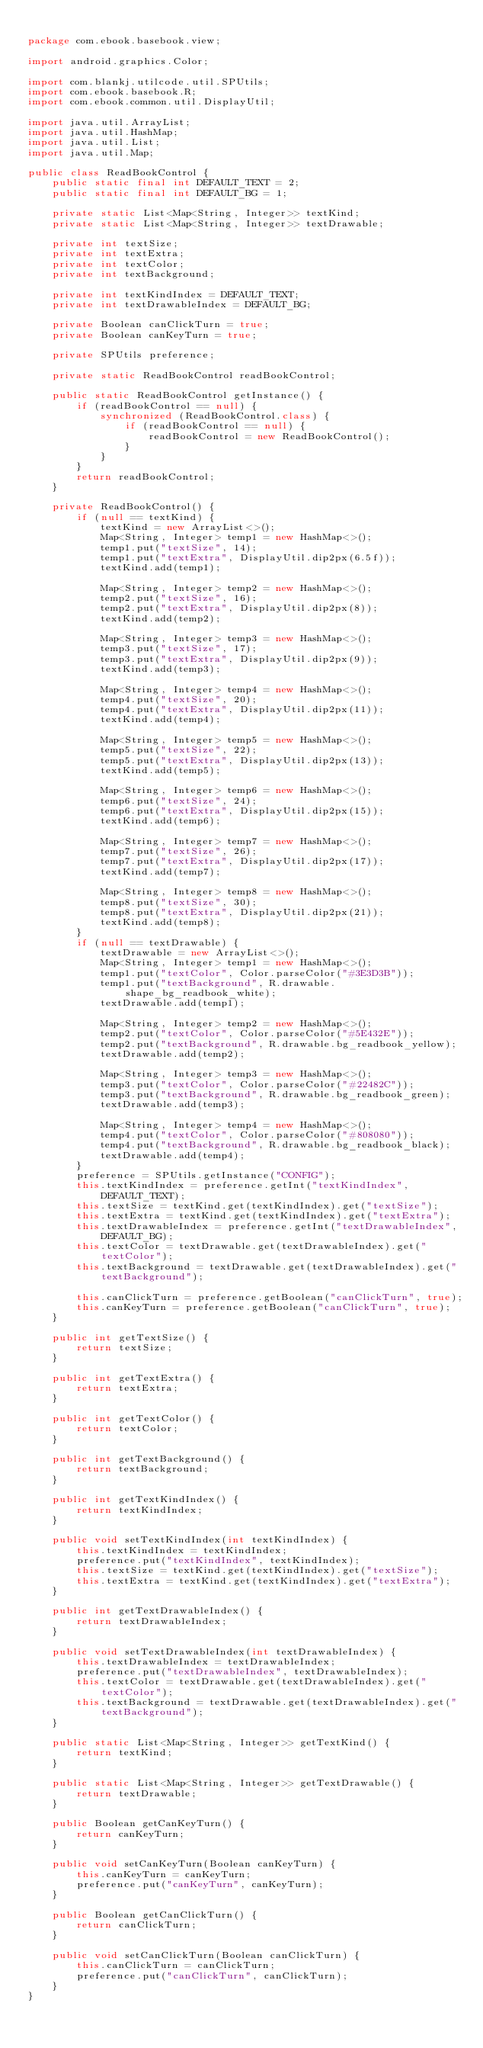<code> <loc_0><loc_0><loc_500><loc_500><_Java_>
package com.ebook.basebook.view;

import android.graphics.Color;

import com.blankj.utilcode.util.SPUtils;
import com.ebook.basebook.R;
import com.ebook.common.util.DisplayUtil;

import java.util.ArrayList;
import java.util.HashMap;
import java.util.List;
import java.util.Map;

public class ReadBookControl {
    public static final int DEFAULT_TEXT = 2;
    public static final int DEFAULT_BG = 1;

    private static List<Map<String, Integer>> textKind;
    private static List<Map<String, Integer>> textDrawable;

    private int textSize;
    private int textExtra;
    private int textColor;
    private int textBackground;

    private int textKindIndex = DEFAULT_TEXT;
    private int textDrawableIndex = DEFAULT_BG;

    private Boolean canClickTurn = true;
    private Boolean canKeyTurn = true;

    private SPUtils preference;

    private static ReadBookControl readBookControl;

    public static ReadBookControl getInstance() {
        if (readBookControl == null) {
            synchronized (ReadBookControl.class) {
                if (readBookControl == null) {
                    readBookControl = new ReadBookControl();
                }
            }
        }
        return readBookControl;
    }

    private ReadBookControl() {
        if (null == textKind) {
            textKind = new ArrayList<>();
            Map<String, Integer> temp1 = new HashMap<>();
            temp1.put("textSize", 14);
            temp1.put("textExtra", DisplayUtil.dip2px(6.5f));
            textKind.add(temp1);

            Map<String, Integer> temp2 = new HashMap<>();
            temp2.put("textSize", 16);
            temp2.put("textExtra", DisplayUtil.dip2px(8));
            textKind.add(temp2);

            Map<String, Integer> temp3 = new HashMap<>();
            temp3.put("textSize", 17);
            temp3.put("textExtra", DisplayUtil.dip2px(9));
            textKind.add(temp3);

            Map<String, Integer> temp4 = new HashMap<>();
            temp4.put("textSize", 20);
            temp4.put("textExtra", DisplayUtil.dip2px(11));
            textKind.add(temp4);

            Map<String, Integer> temp5 = new HashMap<>();
            temp5.put("textSize", 22);
            temp5.put("textExtra", DisplayUtil.dip2px(13));
            textKind.add(temp5);

            Map<String, Integer> temp6 = new HashMap<>();
            temp6.put("textSize", 24);
            temp6.put("textExtra", DisplayUtil.dip2px(15));
            textKind.add(temp6);

            Map<String, Integer> temp7 = new HashMap<>();
            temp7.put("textSize", 26);
            temp7.put("textExtra", DisplayUtil.dip2px(17));
            textKind.add(temp7);

            Map<String, Integer> temp8 = new HashMap<>();
            temp8.put("textSize", 30);
            temp8.put("textExtra", DisplayUtil.dip2px(21));
            textKind.add(temp8);
        }
        if (null == textDrawable) {
            textDrawable = new ArrayList<>();
            Map<String, Integer> temp1 = new HashMap<>();
            temp1.put("textColor", Color.parseColor("#3E3D3B"));
            temp1.put("textBackground", R.drawable.shape_bg_readbook_white);
            textDrawable.add(temp1);

            Map<String, Integer> temp2 = new HashMap<>();
            temp2.put("textColor", Color.parseColor("#5E432E"));
            temp2.put("textBackground", R.drawable.bg_readbook_yellow);
            textDrawable.add(temp2);

            Map<String, Integer> temp3 = new HashMap<>();
            temp3.put("textColor", Color.parseColor("#22482C"));
            temp3.put("textBackground", R.drawable.bg_readbook_green);
            textDrawable.add(temp3);

            Map<String, Integer> temp4 = new HashMap<>();
            temp4.put("textColor", Color.parseColor("#808080"));
            temp4.put("textBackground", R.drawable.bg_readbook_black);
            textDrawable.add(temp4);
        }
        preference = SPUtils.getInstance("CONFIG");
        this.textKindIndex = preference.getInt("textKindIndex", DEFAULT_TEXT);
        this.textSize = textKind.get(textKindIndex).get("textSize");
        this.textExtra = textKind.get(textKindIndex).get("textExtra");
        this.textDrawableIndex = preference.getInt("textDrawableIndex", DEFAULT_BG);
        this.textColor = textDrawable.get(textDrawableIndex).get("textColor");
        this.textBackground = textDrawable.get(textDrawableIndex).get("textBackground");

        this.canClickTurn = preference.getBoolean("canClickTurn", true);
        this.canKeyTurn = preference.getBoolean("canClickTurn", true);
    }

    public int getTextSize() {
        return textSize;
    }

    public int getTextExtra() {
        return textExtra;
    }

    public int getTextColor() {
        return textColor;
    }

    public int getTextBackground() {
        return textBackground;
    }

    public int getTextKindIndex() {
        return textKindIndex;
    }

    public void setTextKindIndex(int textKindIndex) {
        this.textKindIndex = textKindIndex;
        preference.put("textKindIndex", textKindIndex);
        this.textSize = textKind.get(textKindIndex).get("textSize");
        this.textExtra = textKind.get(textKindIndex).get("textExtra");
    }

    public int getTextDrawableIndex() {
        return textDrawableIndex;
    }

    public void setTextDrawableIndex(int textDrawableIndex) {
        this.textDrawableIndex = textDrawableIndex;
        preference.put("textDrawableIndex", textDrawableIndex);
        this.textColor = textDrawable.get(textDrawableIndex).get("textColor");
        this.textBackground = textDrawable.get(textDrawableIndex).get("textBackground");
    }

    public static List<Map<String, Integer>> getTextKind() {
        return textKind;
    }

    public static List<Map<String, Integer>> getTextDrawable() {
        return textDrawable;
    }

    public Boolean getCanKeyTurn() {
        return canKeyTurn;
    }

    public void setCanKeyTurn(Boolean canKeyTurn) {
        this.canKeyTurn = canKeyTurn;
        preference.put("canKeyTurn", canKeyTurn);
    }

    public Boolean getCanClickTurn() {
        return canClickTurn;
    }

    public void setCanClickTurn(Boolean canClickTurn) {
        this.canClickTurn = canClickTurn;
        preference.put("canClickTurn", canClickTurn);
    }
}</code> 